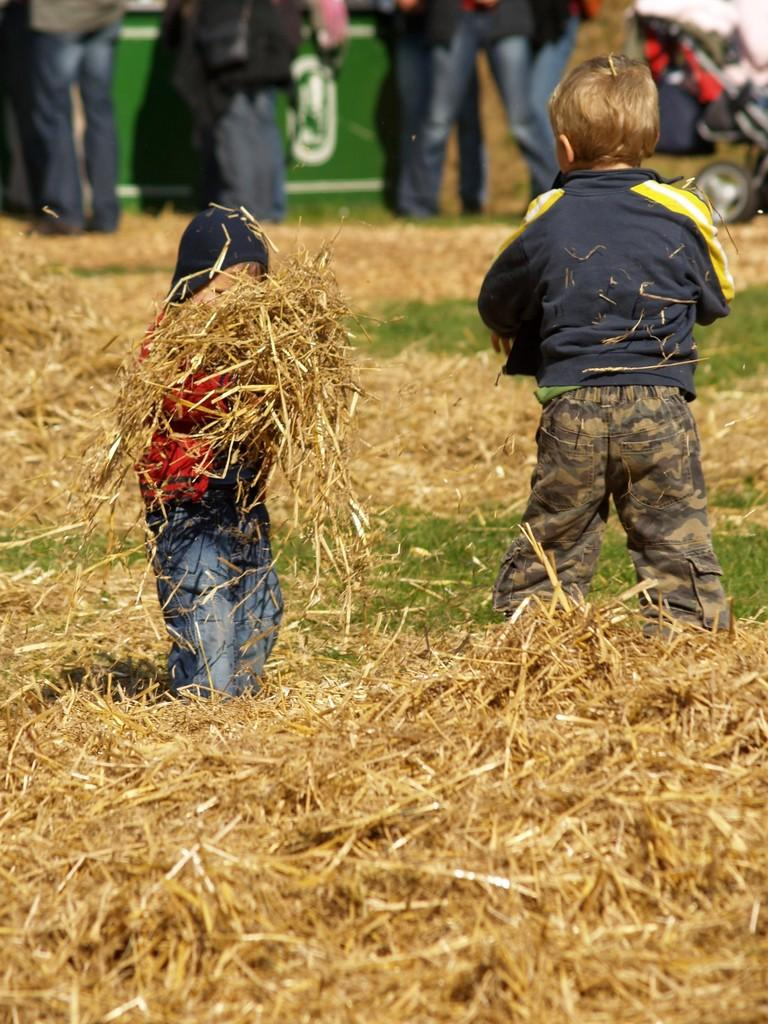How many kids are in the image? There are two kids in the image. What are the kids doing in the image? The kids are standing in the image. What type of surface is at the bottom of the image? There is grass at the bottom of the image. Can you describe the background of the image? There are people standing in the background of the image. What type of frame is around the image? There is no frame around the image; it is a photograph or digital image without a physical frame. 